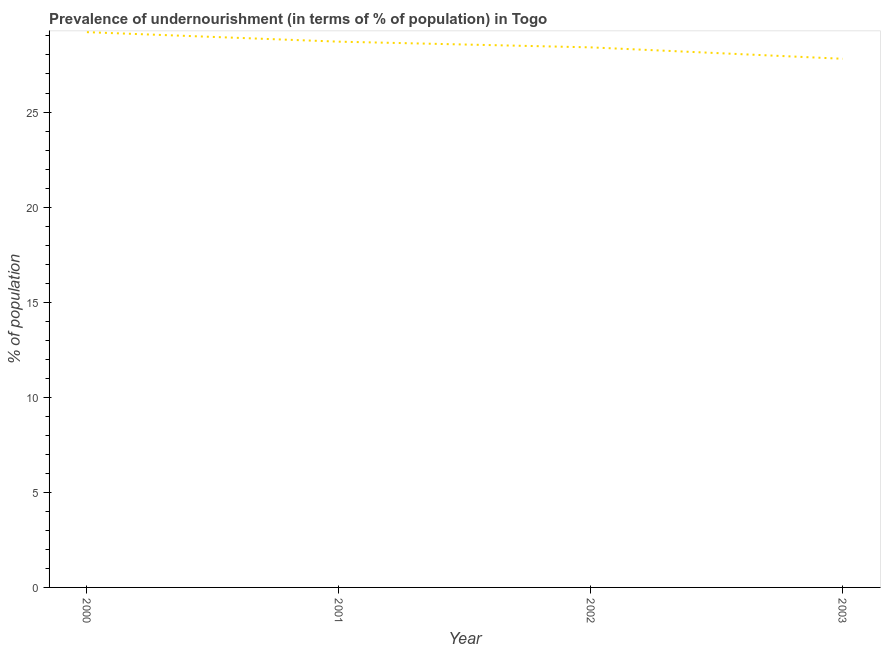What is the percentage of undernourished population in 2002?
Keep it short and to the point. 28.4. Across all years, what is the maximum percentage of undernourished population?
Offer a very short reply. 29.2. Across all years, what is the minimum percentage of undernourished population?
Your answer should be very brief. 27.8. What is the sum of the percentage of undernourished population?
Provide a succinct answer. 114.1. What is the difference between the percentage of undernourished population in 2001 and 2002?
Provide a succinct answer. 0.3. What is the average percentage of undernourished population per year?
Offer a terse response. 28.52. What is the median percentage of undernourished population?
Offer a terse response. 28.55. In how many years, is the percentage of undernourished population greater than 18 %?
Provide a succinct answer. 4. Do a majority of the years between 2001 and 2000 (inclusive) have percentage of undernourished population greater than 6 %?
Your answer should be compact. No. What is the ratio of the percentage of undernourished population in 2001 to that in 2003?
Give a very brief answer. 1.03. Is the percentage of undernourished population in 2001 less than that in 2003?
Offer a very short reply. No. Is the difference between the percentage of undernourished population in 2002 and 2003 greater than the difference between any two years?
Provide a succinct answer. No. Is the sum of the percentage of undernourished population in 2000 and 2001 greater than the maximum percentage of undernourished population across all years?
Make the answer very short. Yes. What is the difference between the highest and the lowest percentage of undernourished population?
Give a very brief answer. 1.4. Does the percentage of undernourished population monotonically increase over the years?
Provide a succinct answer. No. How many years are there in the graph?
Make the answer very short. 4. Are the values on the major ticks of Y-axis written in scientific E-notation?
Give a very brief answer. No. What is the title of the graph?
Your response must be concise. Prevalence of undernourishment (in terms of % of population) in Togo. What is the label or title of the X-axis?
Offer a very short reply. Year. What is the label or title of the Y-axis?
Your response must be concise. % of population. What is the % of population of 2000?
Give a very brief answer. 29.2. What is the % of population in 2001?
Make the answer very short. 28.7. What is the % of population in 2002?
Your answer should be very brief. 28.4. What is the % of population in 2003?
Ensure brevity in your answer.  27.8. What is the difference between the % of population in 2000 and 2001?
Your answer should be compact. 0.5. What is the difference between the % of population in 2000 and 2003?
Offer a very short reply. 1.4. What is the difference between the % of population in 2001 and 2002?
Provide a succinct answer. 0.3. What is the difference between the % of population in 2001 and 2003?
Your answer should be compact. 0.9. What is the ratio of the % of population in 2000 to that in 2002?
Provide a short and direct response. 1.03. What is the ratio of the % of population in 2001 to that in 2002?
Make the answer very short. 1.01. What is the ratio of the % of population in 2001 to that in 2003?
Provide a short and direct response. 1.03. What is the ratio of the % of population in 2002 to that in 2003?
Provide a short and direct response. 1.02. 